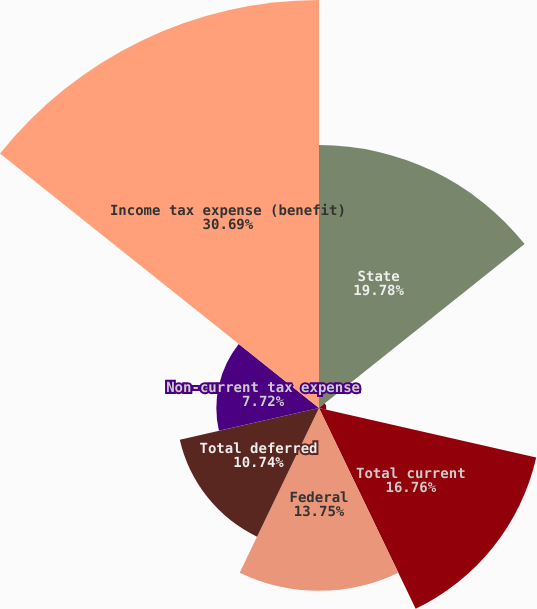<chart> <loc_0><loc_0><loc_500><loc_500><pie_chart><fcel>State<fcel>Foreign<fcel>Total current<fcel>Federal<fcel>Total deferred<fcel>Non-current tax expense<fcel>Income tax expense (benefit)<nl><fcel>19.78%<fcel>0.56%<fcel>16.76%<fcel>13.75%<fcel>10.74%<fcel>7.72%<fcel>30.69%<nl></chart> 